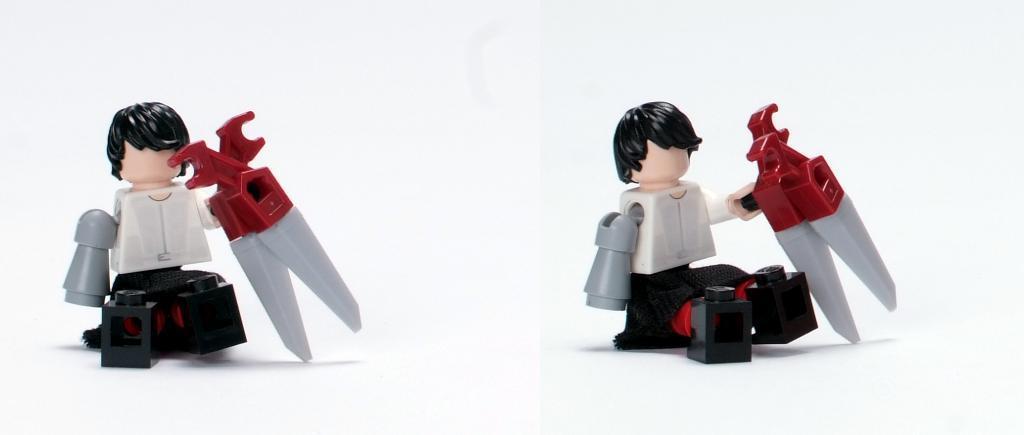Describe this image in one or two sentences. In the picture there are two different images collage together, there are two toys in the image both the toys are of similar type. 